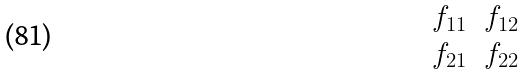Convert formula to latex. <formula><loc_0><loc_0><loc_500><loc_500>\begin{matrix} f _ { 1 1 } & f _ { 1 2 } \\ f _ { 2 1 } & f _ { 2 2 } \end{matrix}</formula> 